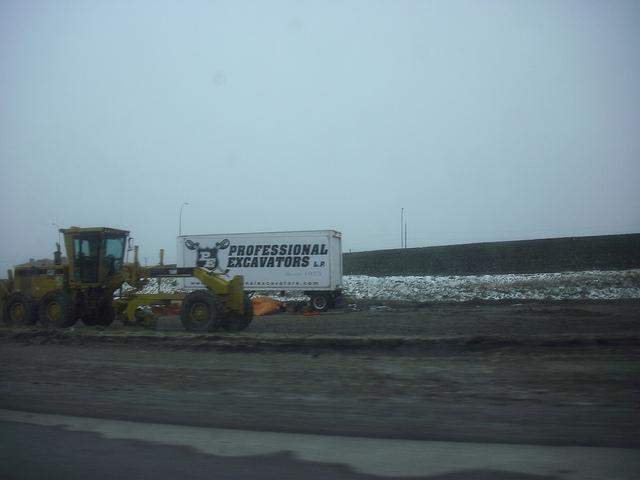What color is the truck?
Short answer required. White. Is the photo colorful?
Be succinct. No. Is the car moving?
Give a very brief answer. No. Is the writing in cursive?
Quick response, please. No. What type of equipment is the yellow machine?
Give a very brief answer. Excavator. Is there a bird in the sky?
Short answer required. No. Do you see any trees?
Give a very brief answer. No. What kind of truck is this?
Concise answer only. Tractor. What does the semi trailer say?
Quick response, please. Professional excavators. Does it snow here?
Quick response, please. Yes. What kind of work might they be doing?
Give a very brief answer. Excavation. Is there a bridge in this photo?
Short answer required. No. How many trains are pictured?
Answer briefly. 0. Is there a shade of pink?
Write a very short answer. No. Could you enjoy pizza at the beach?
Keep it brief. Yes. What is the object on the left?
Be succinct. Tractor. What did Mike build in the sand?
Concise answer only. Nothing. Are there people seen?
Give a very brief answer. No. 